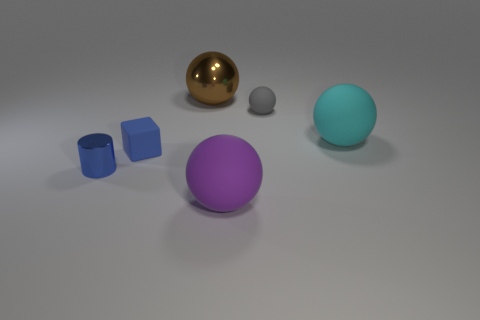Subtract all yellow balls. Subtract all yellow cubes. How many balls are left? 4 Add 4 tiny shiny cylinders. How many objects exist? 10 Subtract all blocks. How many objects are left? 5 Add 4 big red rubber balls. How many big red rubber balls exist? 4 Subtract 0 yellow balls. How many objects are left? 6 Subtract all large purple matte objects. Subtract all tiny matte balls. How many objects are left? 4 Add 4 tiny cylinders. How many tiny cylinders are left? 5 